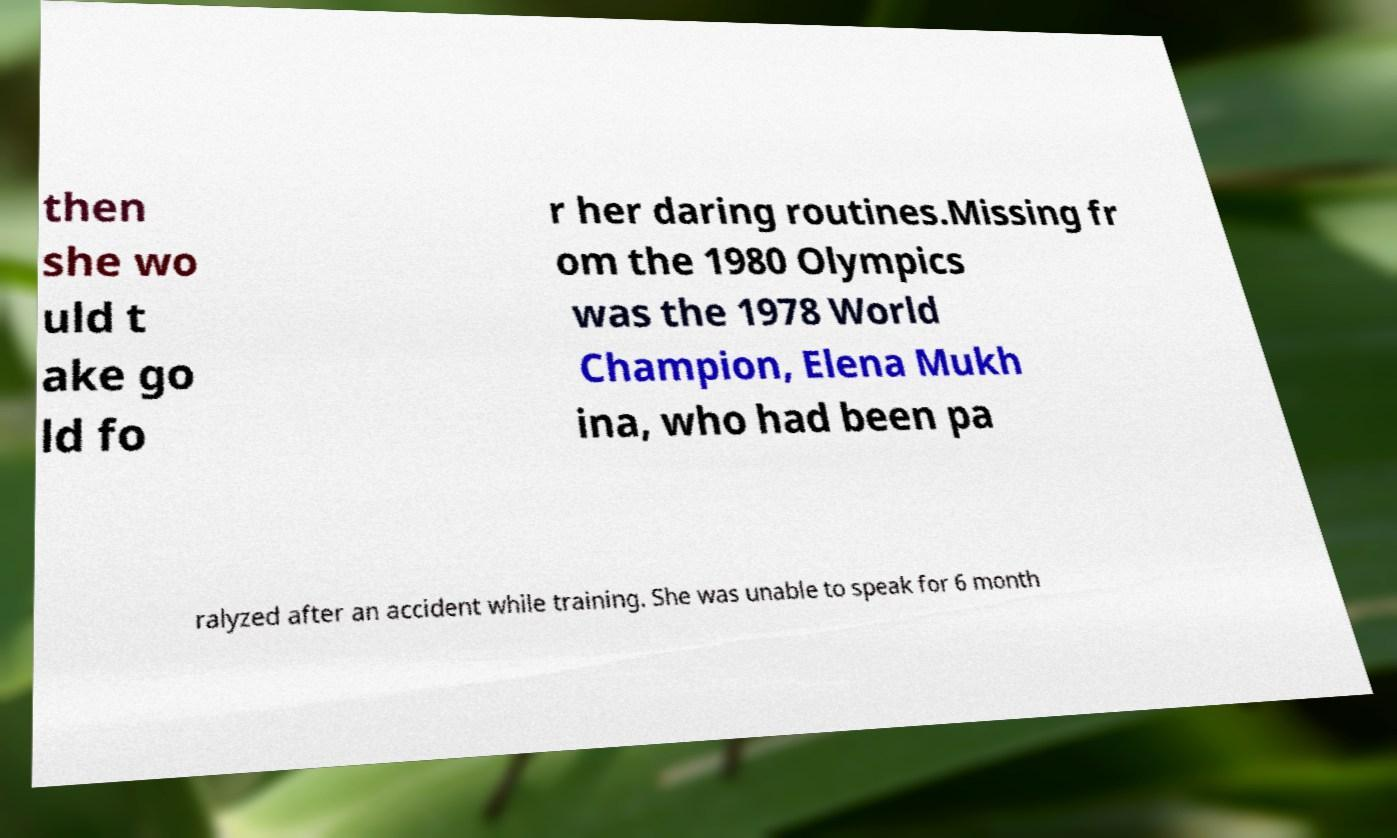Please read and relay the text visible in this image. What does it say? then she wo uld t ake go ld fo r her daring routines.Missing fr om the 1980 Olympics was the 1978 World Champion, Elena Mukh ina, who had been pa ralyzed after an accident while training. She was unable to speak for 6 month 